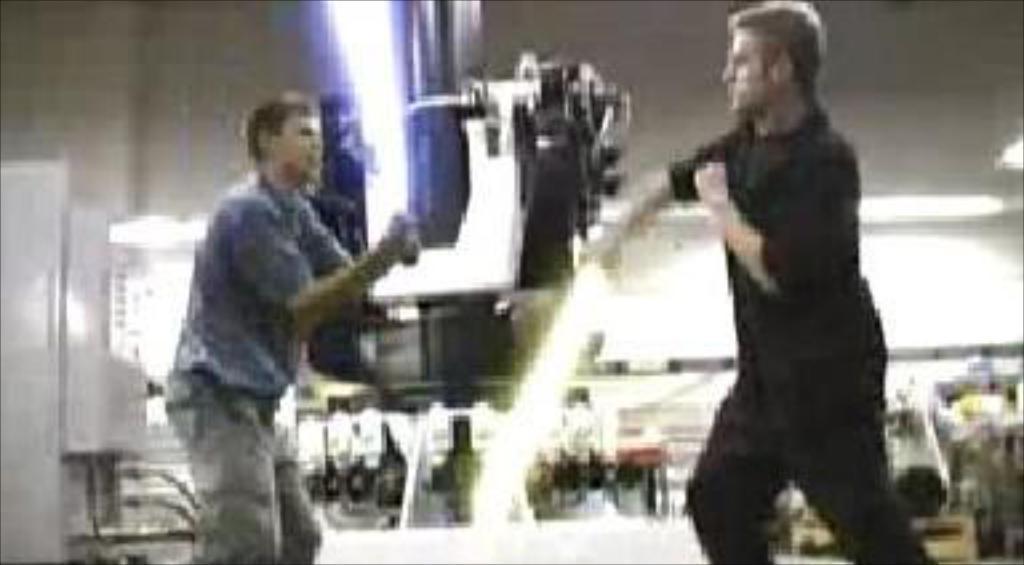In one or two sentences, can you explain what this image depicts? In this image we can see men standing on the ground. 